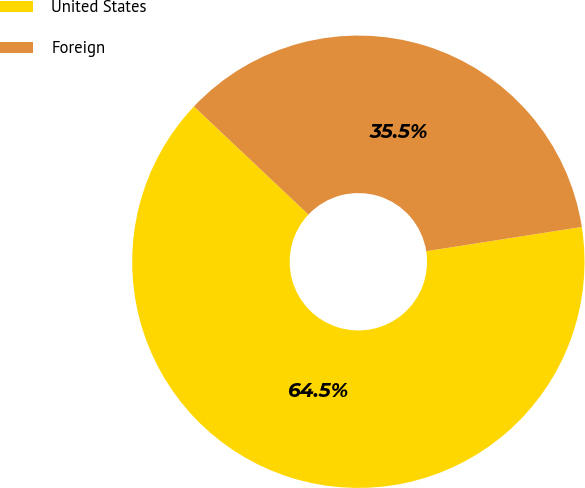Convert chart to OTSL. <chart><loc_0><loc_0><loc_500><loc_500><pie_chart><fcel>United States<fcel>Foreign<nl><fcel>64.51%<fcel>35.49%<nl></chart> 